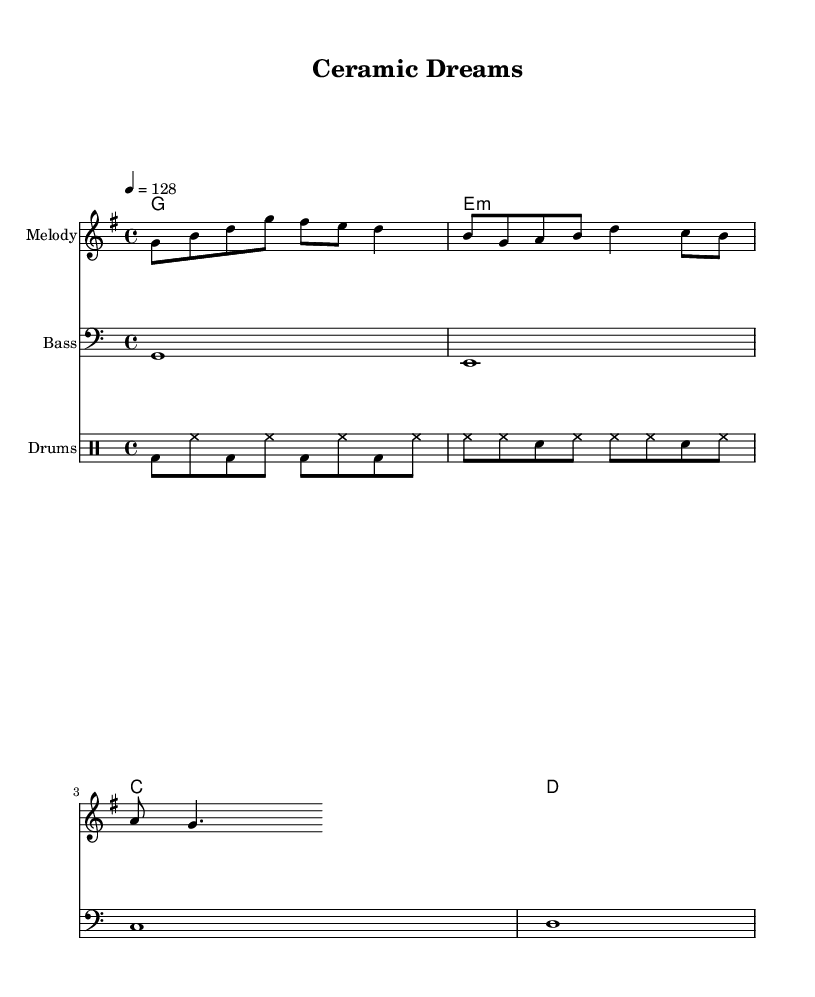What is the key signature of this music? The key signature is G major, which has one sharp (F#) indicated by the key signature at the beginning of the first staff.
Answer: G major What is the time signature of this music? The time signature is 4/4, which is shown at the beginning of the score indicating that there are four beats in each measure.
Answer: 4/4 What is the tempo marking of this piece? The tempo marking indicates a speed of 128 beats per minute, noted as "4 = 128" which means there are 128 quarter-note beats in one minute.
Answer: 128 How many measures are there in the melody? By counting the measures in the melody staff, there are a total of three measures. Each group of notes between the bar lines represents a measure.
Answer: 3 What is the chord progression used in the harmony? The chord progression is G major, E minor, C major, and D major, represented by their chord symbols written above the melody throughout the measures.
Answer: G, E minor, C, D What instrument is indicated for the melody? The instrument for the melody part is labeled as "Melody" in the staff title, indicating it will be played on a melodic instrument, likely a lead vocal or synth in K-pop.
Answer: Melody What rhythmic pattern is used for the drums? The drum part exhibits a rhythmic pattern of bass drum and hi-hat primarily, with specific note placements in each measure showcasing a common upbeat K-pop rhythm.
Answer: Bass and hi-hat 